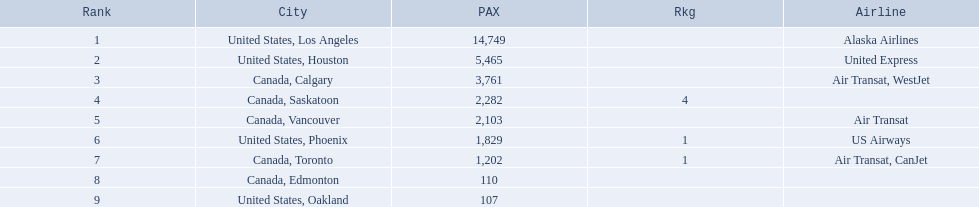Which airport has the least amount of passengers? 107. What airport has 107 passengers? United States, Oakland. 